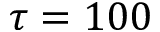Convert formula to latex. <formula><loc_0><loc_0><loc_500><loc_500>\tau = 1 0 0</formula> 